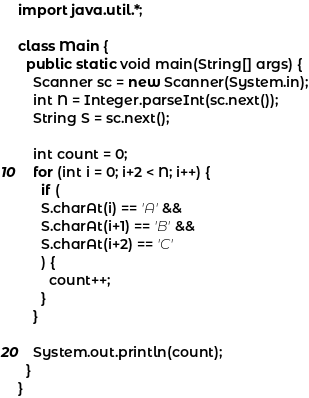Convert code to text. <code><loc_0><loc_0><loc_500><loc_500><_Java_>import java.util.*;

class Main {
  public static void main(String[] args) {
    Scanner sc = new Scanner(System.in);
    int N = Integer.parseInt(sc.next());
    String S = sc.next();
    
    int count = 0;
    for (int i = 0; i+2 < N; i++) {
      if (
      S.charAt(i) == 'A' &&
      S.charAt(i+1) == 'B' &&
      S.charAt(i+2) == 'C'
      ) {
        count++;
      }
    }
    
    System.out.println(count);
  }
}</code> 